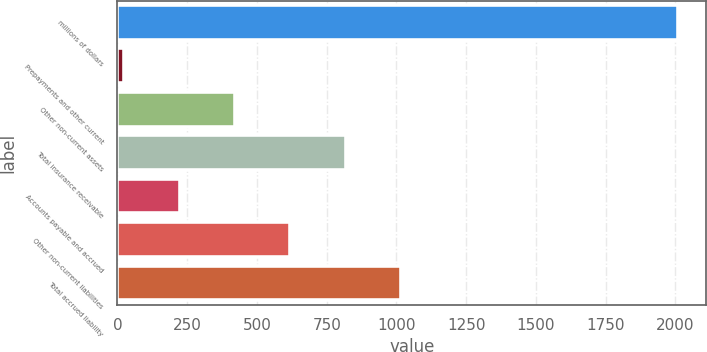<chart> <loc_0><loc_0><loc_500><loc_500><bar_chart><fcel>millions of dollars<fcel>Prepayments and other current<fcel>Other non-current assets<fcel>Total insurance receivable<fcel>Accounts payable and accrued<fcel>Other non-current liabilities<fcel>Total accrued liability<nl><fcel>2009<fcel>24.9<fcel>421.72<fcel>818.54<fcel>223.31<fcel>620.13<fcel>1016.95<nl></chart> 